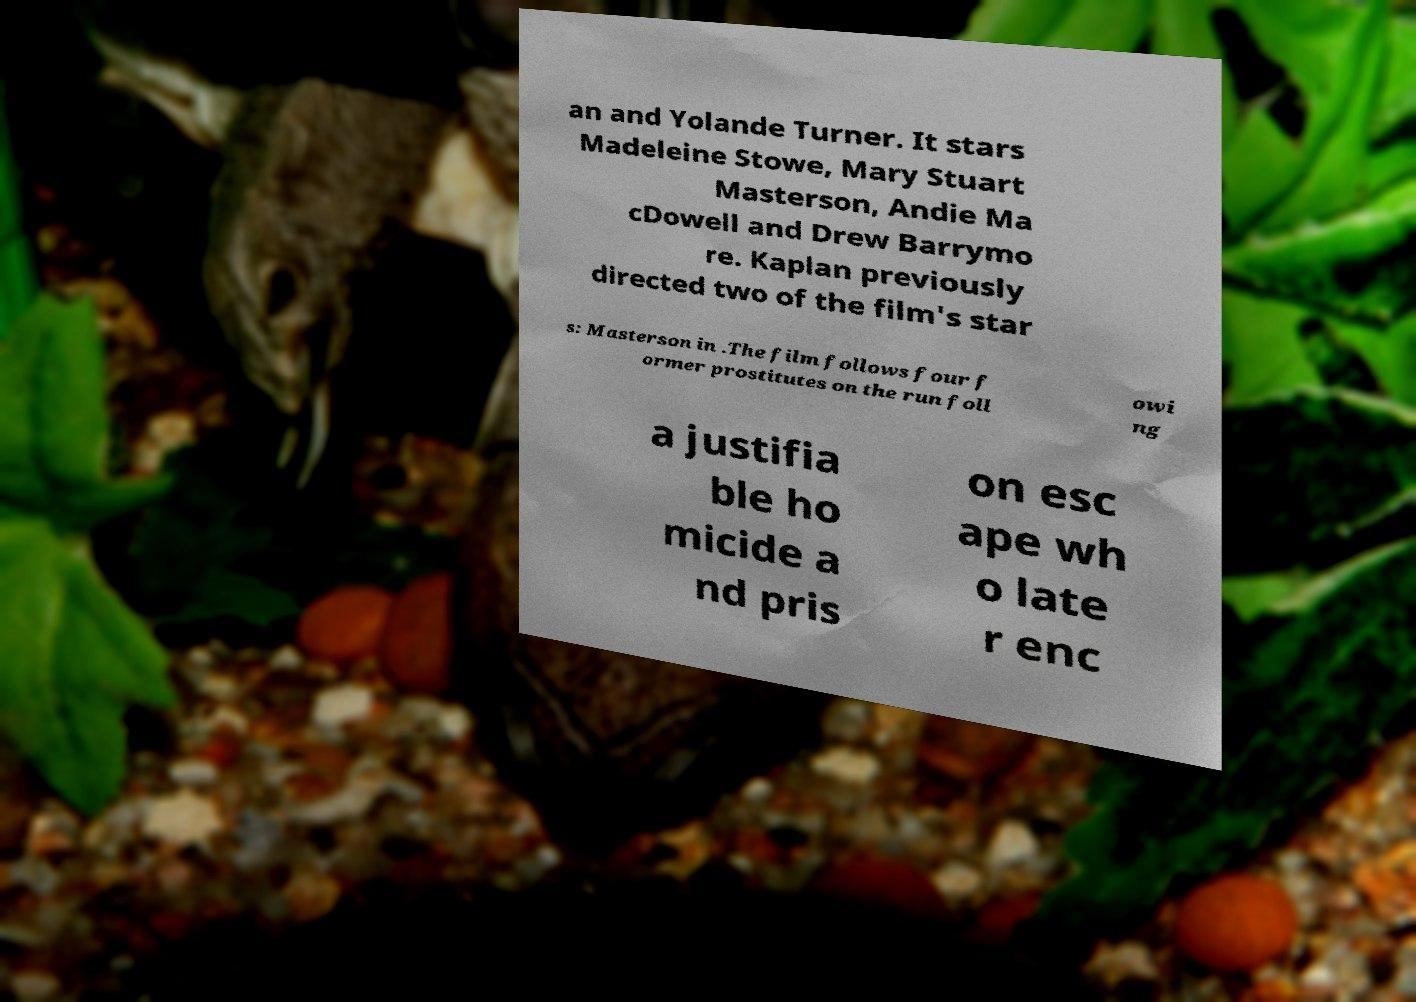Could you extract and type out the text from this image? an and Yolande Turner. It stars Madeleine Stowe, Mary Stuart Masterson, Andie Ma cDowell and Drew Barrymo re. Kaplan previously directed two of the film's star s: Masterson in .The film follows four f ormer prostitutes on the run foll owi ng a justifia ble ho micide a nd pris on esc ape wh o late r enc 